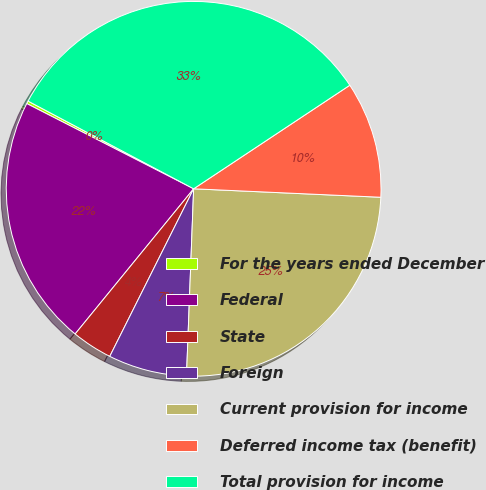Convert chart to OTSL. <chart><loc_0><loc_0><loc_500><loc_500><pie_chart><fcel>For the years ended December<fcel>Federal<fcel>State<fcel>Foreign<fcel>Current provision for income<fcel>Deferred income tax (benefit)<fcel>Total provision for income<nl><fcel>0.24%<fcel>21.62%<fcel>3.51%<fcel>6.78%<fcel>24.89%<fcel>10.04%<fcel>32.93%<nl></chart> 